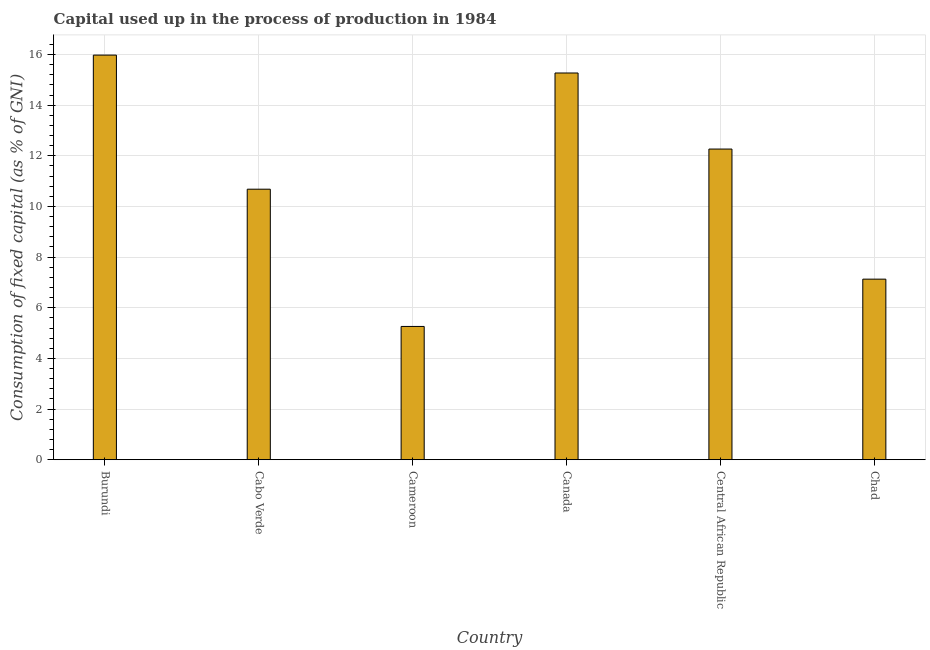Does the graph contain any zero values?
Offer a terse response. No. Does the graph contain grids?
Your response must be concise. Yes. What is the title of the graph?
Your response must be concise. Capital used up in the process of production in 1984. What is the label or title of the Y-axis?
Keep it short and to the point. Consumption of fixed capital (as % of GNI). What is the consumption of fixed capital in Chad?
Give a very brief answer. 7.13. Across all countries, what is the maximum consumption of fixed capital?
Provide a short and direct response. 15.98. Across all countries, what is the minimum consumption of fixed capital?
Provide a succinct answer. 5.26. In which country was the consumption of fixed capital maximum?
Your answer should be very brief. Burundi. In which country was the consumption of fixed capital minimum?
Your answer should be very brief. Cameroon. What is the sum of the consumption of fixed capital?
Provide a succinct answer. 66.59. What is the difference between the consumption of fixed capital in Cameroon and Canada?
Make the answer very short. -10.01. What is the average consumption of fixed capital per country?
Give a very brief answer. 11.1. What is the median consumption of fixed capital?
Your answer should be very brief. 11.47. What is the ratio of the consumption of fixed capital in Burundi to that in Chad?
Give a very brief answer. 2.24. Is the consumption of fixed capital in Burundi less than that in Canada?
Your answer should be compact. No. What is the difference between the highest and the second highest consumption of fixed capital?
Provide a succinct answer. 0.71. What is the difference between the highest and the lowest consumption of fixed capital?
Offer a terse response. 10.71. Are all the bars in the graph horizontal?
Offer a terse response. No. How many countries are there in the graph?
Ensure brevity in your answer.  6. Are the values on the major ticks of Y-axis written in scientific E-notation?
Make the answer very short. No. What is the Consumption of fixed capital (as % of GNI) in Burundi?
Ensure brevity in your answer.  15.98. What is the Consumption of fixed capital (as % of GNI) of Cabo Verde?
Make the answer very short. 10.68. What is the Consumption of fixed capital (as % of GNI) of Cameroon?
Ensure brevity in your answer.  5.26. What is the Consumption of fixed capital (as % of GNI) in Canada?
Make the answer very short. 15.27. What is the Consumption of fixed capital (as % of GNI) in Central African Republic?
Provide a succinct answer. 12.27. What is the Consumption of fixed capital (as % of GNI) of Chad?
Your response must be concise. 7.13. What is the difference between the Consumption of fixed capital (as % of GNI) in Burundi and Cabo Verde?
Provide a short and direct response. 5.3. What is the difference between the Consumption of fixed capital (as % of GNI) in Burundi and Cameroon?
Offer a very short reply. 10.71. What is the difference between the Consumption of fixed capital (as % of GNI) in Burundi and Canada?
Offer a terse response. 0.71. What is the difference between the Consumption of fixed capital (as % of GNI) in Burundi and Central African Republic?
Provide a succinct answer. 3.71. What is the difference between the Consumption of fixed capital (as % of GNI) in Burundi and Chad?
Ensure brevity in your answer.  8.85. What is the difference between the Consumption of fixed capital (as % of GNI) in Cabo Verde and Cameroon?
Your response must be concise. 5.42. What is the difference between the Consumption of fixed capital (as % of GNI) in Cabo Verde and Canada?
Your answer should be very brief. -4.59. What is the difference between the Consumption of fixed capital (as % of GNI) in Cabo Verde and Central African Republic?
Your answer should be compact. -1.59. What is the difference between the Consumption of fixed capital (as % of GNI) in Cabo Verde and Chad?
Provide a short and direct response. 3.55. What is the difference between the Consumption of fixed capital (as % of GNI) in Cameroon and Canada?
Your response must be concise. -10.01. What is the difference between the Consumption of fixed capital (as % of GNI) in Cameroon and Central African Republic?
Provide a short and direct response. -7. What is the difference between the Consumption of fixed capital (as % of GNI) in Cameroon and Chad?
Make the answer very short. -1.87. What is the difference between the Consumption of fixed capital (as % of GNI) in Canada and Central African Republic?
Give a very brief answer. 3. What is the difference between the Consumption of fixed capital (as % of GNI) in Canada and Chad?
Provide a succinct answer. 8.14. What is the difference between the Consumption of fixed capital (as % of GNI) in Central African Republic and Chad?
Give a very brief answer. 5.14. What is the ratio of the Consumption of fixed capital (as % of GNI) in Burundi to that in Cabo Verde?
Provide a short and direct response. 1.5. What is the ratio of the Consumption of fixed capital (as % of GNI) in Burundi to that in Cameroon?
Provide a succinct answer. 3.04. What is the ratio of the Consumption of fixed capital (as % of GNI) in Burundi to that in Canada?
Provide a short and direct response. 1.05. What is the ratio of the Consumption of fixed capital (as % of GNI) in Burundi to that in Central African Republic?
Your answer should be compact. 1.3. What is the ratio of the Consumption of fixed capital (as % of GNI) in Burundi to that in Chad?
Make the answer very short. 2.24. What is the ratio of the Consumption of fixed capital (as % of GNI) in Cabo Verde to that in Cameroon?
Offer a very short reply. 2.03. What is the ratio of the Consumption of fixed capital (as % of GNI) in Cabo Verde to that in Canada?
Your answer should be very brief. 0.7. What is the ratio of the Consumption of fixed capital (as % of GNI) in Cabo Verde to that in Central African Republic?
Offer a terse response. 0.87. What is the ratio of the Consumption of fixed capital (as % of GNI) in Cabo Verde to that in Chad?
Offer a very short reply. 1.5. What is the ratio of the Consumption of fixed capital (as % of GNI) in Cameroon to that in Canada?
Make the answer very short. 0.34. What is the ratio of the Consumption of fixed capital (as % of GNI) in Cameroon to that in Central African Republic?
Give a very brief answer. 0.43. What is the ratio of the Consumption of fixed capital (as % of GNI) in Cameroon to that in Chad?
Offer a terse response. 0.74. What is the ratio of the Consumption of fixed capital (as % of GNI) in Canada to that in Central African Republic?
Your response must be concise. 1.25. What is the ratio of the Consumption of fixed capital (as % of GNI) in Canada to that in Chad?
Provide a succinct answer. 2.14. What is the ratio of the Consumption of fixed capital (as % of GNI) in Central African Republic to that in Chad?
Your answer should be compact. 1.72. 